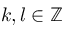Convert formula to latex. <formula><loc_0><loc_0><loc_500><loc_500>k , l \in { \mathbb { Z } }</formula> 